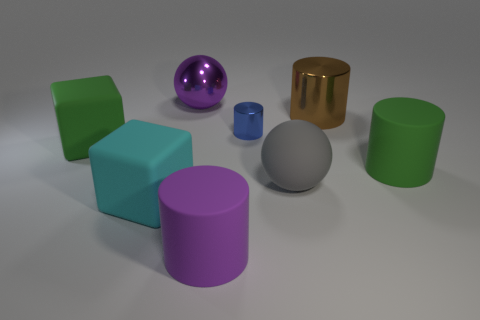Subtract all yellow cylinders. Subtract all brown spheres. How many cylinders are left? 4 Add 2 big purple things. How many objects exist? 10 Subtract all cubes. How many objects are left? 6 Add 4 big purple matte spheres. How many big purple matte spheres exist? 4 Subtract 0 blue blocks. How many objects are left? 8 Subtract all tiny red shiny things. Subtract all gray rubber balls. How many objects are left? 7 Add 2 gray spheres. How many gray spheres are left? 3 